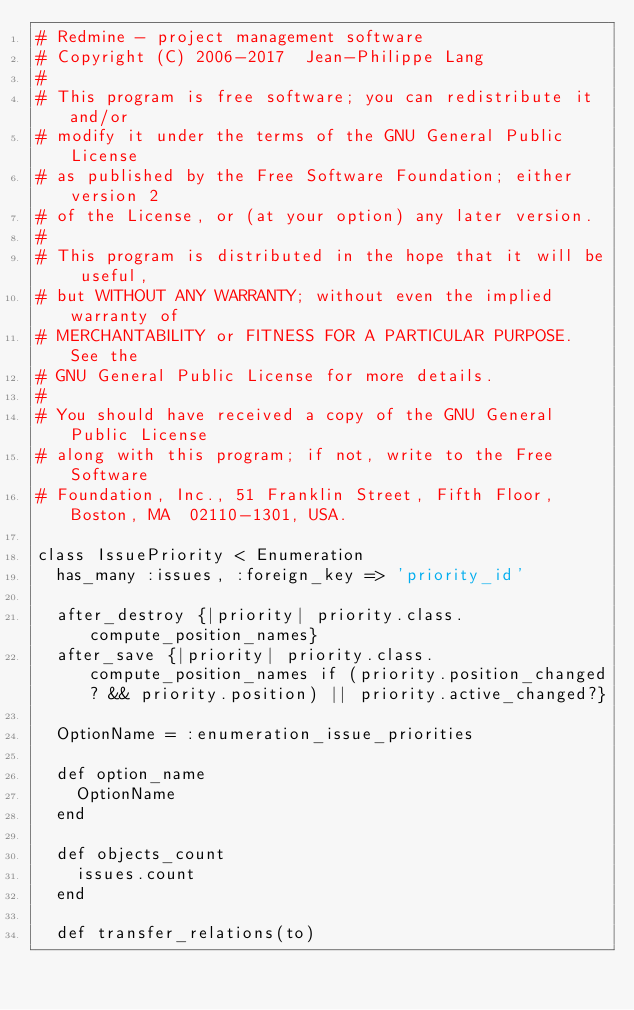Convert code to text. <code><loc_0><loc_0><loc_500><loc_500><_Ruby_># Redmine - project management software
# Copyright (C) 2006-2017  Jean-Philippe Lang
#
# This program is free software; you can redistribute it and/or
# modify it under the terms of the GNU General Public License
# as published by the Free Software Foundation; either version 2
# of the License, or (at your option) any later version.
#
# This program is distributed in the hope that it will be useful,
# but WITHOUT ANY WARRANTY; without even the implied warranty of
# MERCHANTABILITY or FITNESS FOR A PARTICULAR PURPOSE.  See the
# GNU General Public License for more details.
#
# You should have received a copy of the GNU General Public License
# along with this program; if not, write to the Free Software
# Foundation, Inc., 51 Franklin Street, Fifth Floor, Boston, MA  02110-1301, USA.

class IssuePriority < Enumeration
  has_many :issues, :foreign_key => 'priority_id'

  after_destroy {|priority| priority.class.compute_position_names}
  after_save {|priority| priority.class.compute_position_names if (priority.position_changed? && priority.position) || priority.active_changed?}

  OptionName = :enumeration_issue_priorities

  def option_name
    OptionName
  end

  def objects_count
    issues.count
  end

  def transfer_relations(to)</code> 